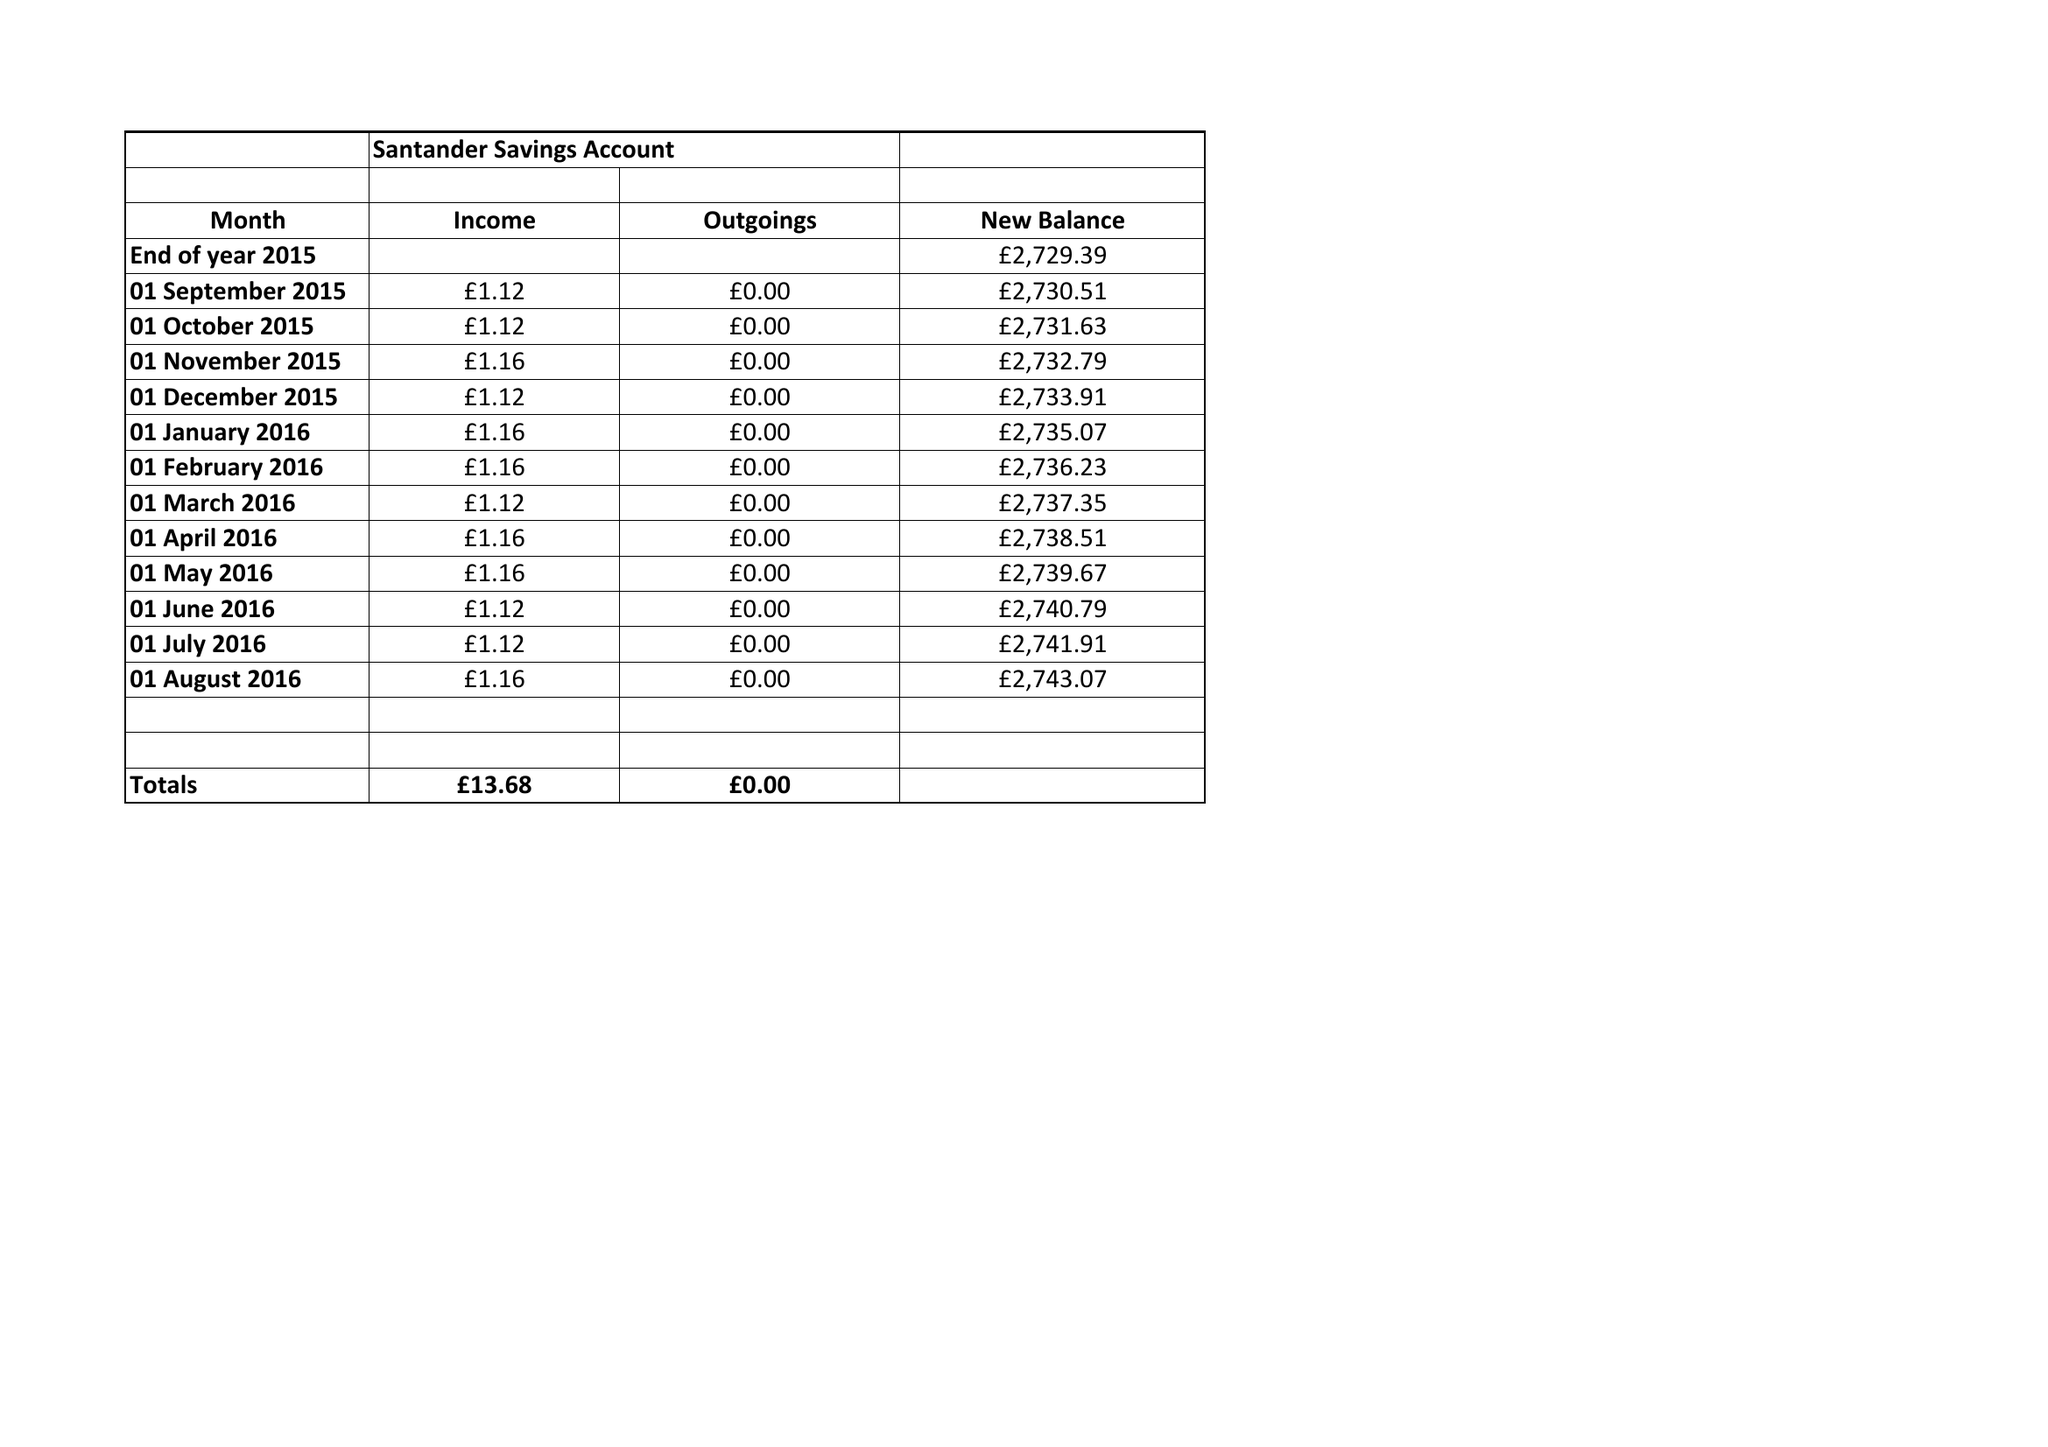What is the value for the report_date?
Answer the question using a single word or phrase. None 